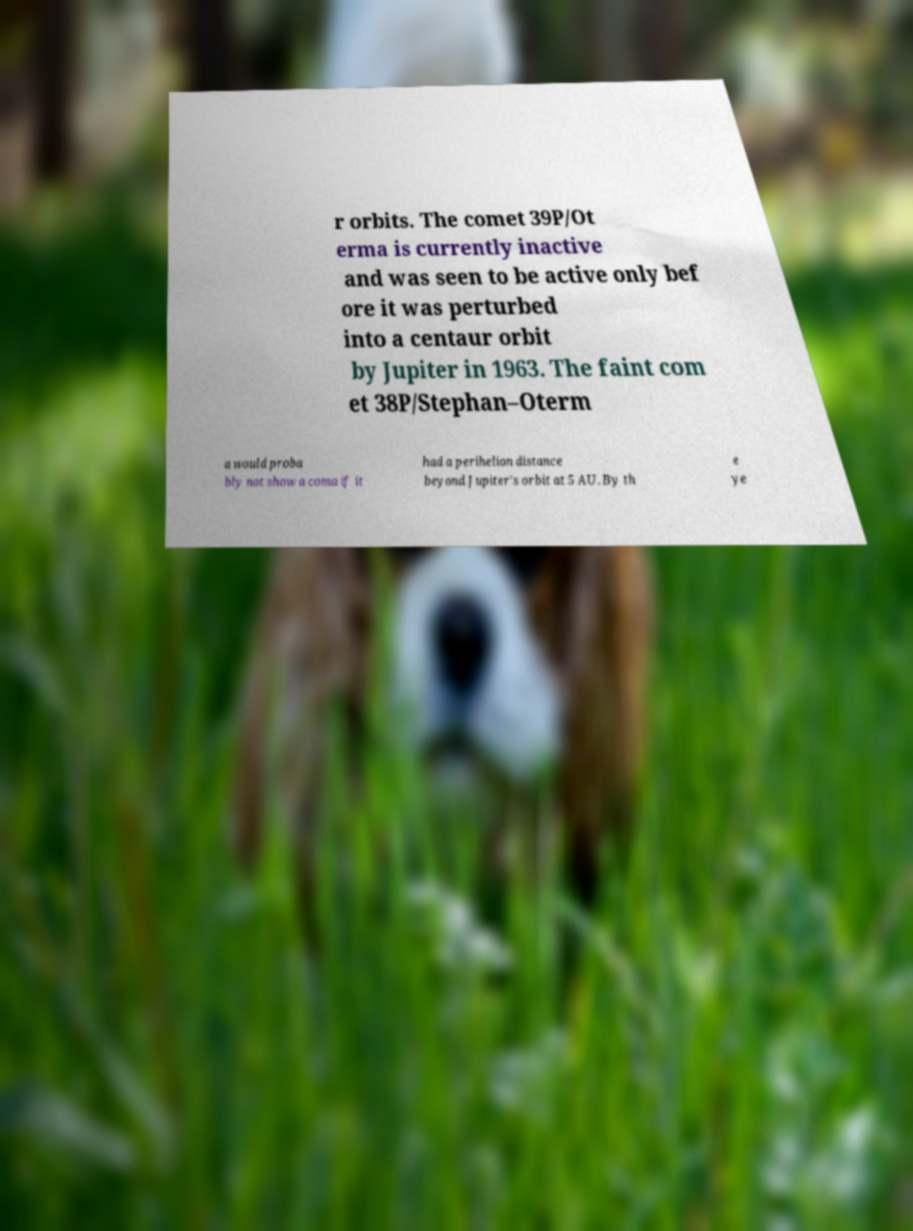Can you accurately transcribe the text from the provided image for me? r orbits. The comet 39P/Ot erma is currently inactive and was seen to be active only bef ore it was perturbed into a centaur orbit by Jupiter in 1963. The faint com et 38P/Stephan–Oterm a would proba bly not show a coma if it had a perihelion distance beyond Jupiter's orbit at 5 AU. By th e ye 